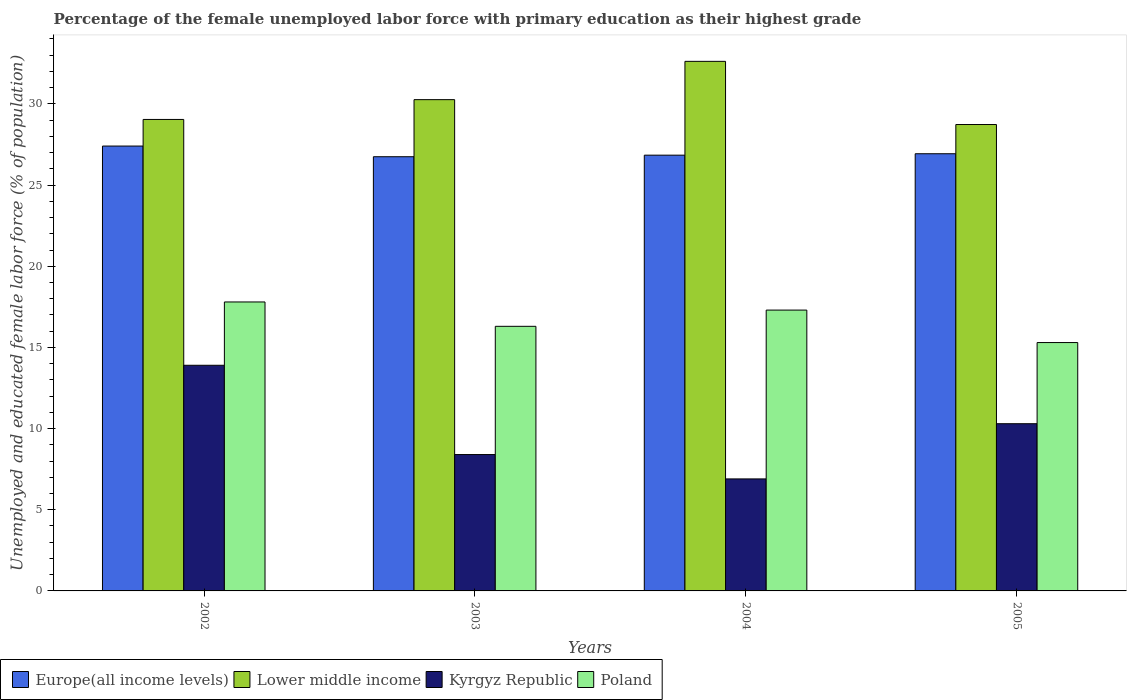How many groups of bars are there?
Make the answer very short. 4. In how many cases, is the number of bars for a given year not equal to the number of legend labels?
Give a very brief answer. 0. What is the percentage of the unemployed female labor force with primary education in Europe(all income levels) in 2002?
Offer a very short reply. 27.4. Across all years, what is the maximum percentage of the unemployed female labor force with primary education in Lower middle income?
Offer a very short reply. 32.62. Across all years, what is the minimum percentage of the unemployed female labor force with primary education in Poland?
Your answer should be very brief. 15.3. In which year was the percentage of the unemployed female labor force with primary education in Kyrgyz Republic maximum?
Provide a succinct answer. 2002. In which year was the percentage of the unemployed female labor force with primary education in Poland minimum?
Keep it short and to the point. 2005. What is the total percentage of the unemployed female labor force with primary education in Kyrgyz Republic in the graph?
Keep it short and to the point. 39.5. What is the difference between the percentage of the unemployed female labor force with primary education in Europe(all income levels) in 2004 and that in 2005?
Your answer should be very brief. -0.09. What is the difference between the percentage of the unemployed female labor force with primary education in Europe(all income levels) in 2003 and the percentage of the unemployed female labor force with primary education in Poland in 2002?
Your response must be concise. 8.95. What is the average percentage of the unemployed female labor force with primary education in Poland per year?
Make the answer very short. 16.67. In the year 2004, what is the difference between the percentage of the unemployed female labor force with primary education in Europe(all income levels) and percentage of the unemployed female labor force with primary education in Lower middle income?
Offer a very short reply. -5.78. In how many years, is the percentage of the unemployed female labor force with primary education in Lower middle income greater than 5 %?
Your response must be concise. 4. What is the ratio of the percentage of the unemployed female labor force with primary education in Europe(all income levels) in 2004 to that in 2005?
Your answer should be very brief. 1. Is the percentage of the unemployed female labor force with primary education in Lower middle income in 2002 less than that in 2004?
Your answer should be compact. Yes. Is the difference between the percentage of the unemployed female labor force with primary education in Europe(all income levels) in 2003 and 2004 greater than the difference between the percentage of the unemployed female labor force with primary education in Lower middle income in 2003 and 2004?
Your answer should be compact. Yes. What is the difference between the highest and the second highest percentage of the unemployed female labor force with primary education in Europe(all income levels)?
Your answer should be very brief. 0.47. What is the difference between the highest and the lowest percentage of the unemployed female labor force with primary education in Lower middle income?
Ensure brevity in your answer.  3.89. Is it the case that in every year, the sum of the percentage of the unemployed female labor force with primary education in Europe(all income levels) and percentage of the unemployed female labor force with primary education in Kyrgyz Republic is greater than the sum of percentage of the unemployed female labor force with primary education in Lower middle income and percentage of the unemployed female labor force with primary education in Poland?
Ensure brevity in your answer.  No. What does the 4th bar from the left in 2004 represents?
Keep it short and to the point. Poland. Is it the case that in every year, the sum of the percentage of the unemployed female labor force with primary education in Poland and percentage of the unemployed female labor force with primary education in Europe(all income levels) is greater than the percentage of the unemployed female labor force with primary education in Lower middle income?
Provide a short and direct response. Yes. Are all the bars in the graph horizontal?
Your answer should be very brief. No. How many years are there in the graph?
Offer a terse response. 4. What is the difference between two consecutive major ticks on the Y-axis?
Your response must be concise. 5. Are the values on the major ticks of Y-axis written in scientific E-notation?
Provide a succinct answer. No. Does the graph contain any zero values?
Make the answer very short. No. Where does the legend appear in the graph?
Provide a succinct answer. Bottom left. How many legend labels are there?
Give a very brief answer. 4. How are the legend labels stacked?
Offer a very short reply. Horizontal. What is the title of the graph?
Keep it short and to the point. Percentage of the female unemployed labor force with primary education as their highest grade. Does "High income: OECD" appear as one of the legend labels in the graph?
Ensure brevity in your answer.  No. What is the label or title of the Y-axis?
Ensure brevity in your answer.  Unemployed and educated female labor force (% of population). What is the Unemployed and educated female labor force (% of population) of Europe(all income levels) in 2002?
Make the answer very short. 27.4. What is the Unemployed and educated female labor force (% of population) of Lower middle income in 2002?
Offer a very short reply. 29.04. What is the Unemployed and educated female labor force (% of population) in Kyrgyz Republic in 2002?
Provide a succinct answer. 13.9. What is the Unemployed and educated female labor force (% of population) in Poland in 2002?
Offer a terse response. 17.8. What is the Unemployed and educated female labor force (% of population) of Europe(all income levels) in 2003?
Keep it short and to the point. 26.75. What is the Unemployed and educated female labor force (% of population) in Lower middle income in 2003?
Your answer should be very brief. 30.26. What is the Unemployed and educated female labor force (% of population) in Kyrgyz Republic in 2003?
Offer a terse response. 8.4. What is the Unemployed and educated female labor force (% of population) of Poland in 2003?
Give a very brief answer. 16.3. What is the Unemployed and educated female labor force (% of population) in Europe(all income levels) in 2004?
Your response must be concise. 26.84. What is the Unemployed and educated female labor force (% of population) in Lower middle income in 2004?
Provide a short and direct response. 32.62. What is the Unemployed and educated female labor force (% of population) of Kyrgyz Republic in 2004?
Offer a terse response. 6.9. What is the Unemployed and educated female labor force (% of population) in Poland in 2004?
Your response must be concise. 17.3. What is the Unemployed and educated female labor force (% of population) of Europe(all income levels) in 2005?
Offer a very short reply. 26.93. What is the Unemployed and educated female labor force (% of population) in Lower middle income in 2005?
Make the answer very short. 28.73. What is the Unemployed and educated female labor force (% of population) in Kyrgyz Republic in 2005?
Your answer should be compact. 10.3. What is the Unemployed and educated female labor force (% of population) in Poland in 2005?
Offer a terse response. 15.3. Across all years, what is the maximum Unemployed and educated female labor force (% of population) of Europe(all income levels)?
Your answer should be very brief. 27.4. Across all years, what is the maximum Unemployed and educated female labor force (% of population) of Lower middle income?
Make the answer very short. 32.62. Across all years, what is the maximum Unemployed and educated female labor force (% of population) in Kyrgyz Republic?
Your response must be concise. 13.9. Across all years, what is the maximum Unemployed and educated female labor force (% of population) of Poland?
Offer a terse response. 17.8. Across all years, what is the minimum Unemployed and educated female labor force (% of population) of Europe(all income levels)?
Offer a very short reply. 26.75. Across all years, what is the minimum Unemployed and educated female labor force (% of population) in Lower middle income?
Ensure brevity in your answer.  28.73. Across all years, what is the minimum Unemployed and educated female labor force (% of population) of Kyrgyz Republic?
Give a very brief answer. 6.9. Across all years, what is the minimum Unemployed and educated female labor force (% of population) in Poland?
Make the answer very short. 15.3. What is the total Unemployed and educated female labor force (% of population) in Europe(all income levels) in the graph?
Your response must be concise. 107.92. What is the total Unemployed and educated female labor force (% of population) in Lower middle income in the graph?
Provide a short and direct response. 120.66. What is the total Unemployed and educated female labor force (% of population) in Kyrgyz Republic in the graph?
Your response must be concise. 39.5. What is the total Unemployed and educated female labor force (% of population) of Poland in the graph?
Ensure brevity in your answer.  66.7. What is the difference between the Unemployed and educated female labor force (% of population) of Europe(all income levels) in 2002 and that in 2003?
Keep it short and to the point. 0.66. What is the difference between the Unemployed and educated female labor force (% of population) in Lower middle income in 2002 and that in 2003?
Offer a terse response. -1.22. What is the difference between the Unemployed and educated female labor force (% of population) in Europe(all income levels) in 2002 and that in 2004?
Ensure brevity in your answer.  0.56. What is the difference between the Unemployed and educated female labor force (% of population) of Lower middle income in 2002 and that in 2004?
Ensure brevity in your answer.  -3.58. What is the difference between the Unemployed and educated female labor force (% of population) of Kyrgyz Republic in 2002 and that in 2004?
Offer a very short reply. 7. What is the difference between the Unemployed and educated female labor force (% of population) in Europe(all income levels) in 2002 and that in 2005?
Offer a terse response. 0.47. What is the difference between the Unemployed and educated female labor force (% of population) in Lower middle income in 2002 and that in 2005?
Your answer should be compact. 0.31. What is the difference between the Unemployed and educated female labor force (% of population) of Kyrgyz Republic in 2002 and that in 2005?
Make the answer very short. 3.6. What is the difference between the Unemployed and educated female labor force (% of population) of Europe(all income levels) in 2003 and that in 2004?
Your answer should be compact. -0.1. What is the difference between the Unemployed and educated female labor force (% of population) of Lower middle income in 2003 and that in 2004?
Provide a succinct answer. -2.36. What is the difference between the Unemployed and educated female labor force (% of population) in Kyrgyz Republic in 2003 and that in 2004?
Your answer should be compact. 1.5. What is the difference between the Unemployed and educated female labor force (% of population) in Poland in 2003 and that in 2004?
Keep it short and to the point. -1. What is the difference between the Unemployed and educated female labor force (% of population) in Europe(all income levels) in 2003 and that in 2005?
Your response must be concise. -0.18. What is the difference between the Unemployed and educated female labor force (% of population) of Lower middle income in 2003 and that in 2005?
Your response must be concise. 1.53. What is the difference between the Unemployed and educated female labor force (% of population) in Kyrgyz Republic in 2003 and that in 2005?
Your response must be concise. -1.9. What is the difference between the Unemployed and educated female labor force (% of population) in Europe(all income levels) in 2004 and that in 2005?
Keep it short and to the point. -0.09. What is the difference between the Unemployed and educated female labor force (% of population) of Lower middle income in 2004 and that in 2005?
Give a very brief answer. 3.89. What is the difference between the Unemployed and educated female labor force (% of population) of Kyrgyz Republic in 2004 and that in 2005?
Your response must be concise. -3.4. What is the difference between the Unemployed and educated female labor force (% of population) in Poland in 2004 and that in 2005?
Give a very brief answer. 2. What is the difference between the Unemployed and educated female labor force (% of population) of Europe(all income levels) in 2002 and the Unemployed and educated female labor force (% of population) of Lower middle income in 2003?
Your response must be concise. -2.86. What is the difference between the Unemployed and educated female labor force (% of population) in Europe(all income levels) in 2002 and the Unemployed and educated female labor force (% of population) in Kyrgyz Republic in 2003?
Your response must be concise. 19. What is the difference between the Unemployed and educated female labor force (% of population) of Europe(all income levels) in 2002 and the Unemployed and educated female labor force (% of population) of Poland in 2003?
Provide a short and direct response. 11.1. What is the difference between the Unemployed and educated female labor force (% of population) in Lower middle income in 2002 and the Unemployed and educated female labor force (% of population) in Kyrgyz Republic in 2003?
Offer a terse response. 20.64. What is the difference between the Unemployed and educated female labor force (% of population) in Lower middle income in 2002 and the Unemployed and educated female labor force (% of population) in Poland in 2003?
Provide a succinct answer. 12.74. What is the difference between the Unemployed and educated female labor force (% of population) in Kyrgyz Republic in 2002 and the Unemployed and educated female labor force (% of population) in Poland in 2003?
Your answer should be compact. -2.4. What is the difference between the Unemployed and educated female labor force (% of population) of Europe(all income levels) in 2002 and the Unemployed and educated female labor force (% of population) of Lower middle income in 2004?
Your answer should be compact. -5.22. What is the difference between the Unemployed and educated female labor force (% of population) of Europe(all income levels) in 2002 and the Unemployed and educated female labor force (% of population) of Kyrgyz Republic in 2004?
Your answer should be very brief. 20.5. What is the difference between the Unemployed and educated female labor force (% of population) of Europe(all income levels) in 2002 and the Unemployed and educated female labor force (% of population) of Poland in 2004?
Offer a terse response. 10.1. What is the difference between the Unemployed and educated female labor force (% of population) of Lower middle income in 2002 and the Unemployed and educated female labor force (% of population) of Kyrgyz Republic in 2004?
Keep it short and to the point. 22.14. What is the difference between the Unemployed and educated female labor force (% of population) in Lower middle income in 2002 and the Unemployed and educated female labor force (% of population) in Poland in 2004?
Make the answer very short. 11.74. What is the difference between the Unemployed and educated female labor force (% of population) in Kyrgyz Republic in 2002 and the Unemployed and educated female labor force (% of population) in Poland in 2004?
Your answer should be very brief. -3.4. What is the difference between the Unemployed and educated female labor force (% of population) of Europe(all income levels) in 2002 and the Unemployed and educated female labor force (% of population) of Lower middle income in 2005?
Your answer should be compact. -1.33. What is the difference between the Unemployed and educated female labor force (% of population) in Europe(all income levels) in 2002 and the Unemployed and educated female labor force (% of population) in Kyrgyz Republic in 2005?
Offer a very short reply. 17.1. What is the difference between the Unemployed and educated female labor force (% of population) of Europe(all income levels) in 2002 and the Unemployed and educated female labor force (% of population) of Poland in 2005?
Your answer should be very brief. 12.1. What is the difference between the Unemployed and educated female labor force (% of population) of Lower middle income in 2002 and the Unemployed and educated female labor force (% of population) of Kyrgyz Republic in 2005?
Your answer should be compact. 18.74. What is the difference between the Unemployed and educated female labor force (% of population) in Lower middle income in 2002 and the Unemployed and educated female labor force (% of population) in Poland in 2005?
Provide a succinct answer. 13.74. What is the difference between the Unemployed and educated female labor force (% of population) of Kyrgyz Republic in 2002 and the Unemployed and educated female labor force (% of population) of Poland in 2005?
Offer a terse response. -1.4. What is the difference between the Unemployed and educated female labor force (% of population) in Europe(all income levels) in 2003 and the Unemployed and educated female labor force (% of population) in Lower middle income in 2004?
Your answer should be compact. -5.87. What is the difference between the Unemployed and educated female labor force (% of population) of Europe(all income levels) in 2003 and the Unemployed and educated female labor force (% of population) of Kyrgyz Republic in 2004?
Provide a short and direct response. 19.85. What is the difference between the Unemployed and educated female labor force (% of population) in Europe(all income levels) in 2003 and the Unemployed and educated female labor force (% of population) in Poland in 2004?
Offer a terse response. 9.45. What is the difference between the Unemployed and educated female labor force (% of population) in Lower middle income in 2003 and the Unemployed and educated female labor force (% of population) in Kyrgyz Republic in 2004?
Give a very brief answer. 23.36. What is the difference between the Unemployed and educated female labor force (% of population) of Lower middle income in 2003 and the Unemployed and educated female labor force (% of population) of Poland in 2004?
Your response must be concise. 12.96. What is the difference between the Unemployed and educated female labor force (% of population) of Europe(all income levels) in 2003 and the Unemployed and educated female labor force (% of population) of Lower middle income in 2005?
Provide a short and direct response. -1.98. What is the difference between the Unemployed and educated female labor force (% of population) in Europe(all income levels) in 2003 and the Unemployed and educated female labor force (% of population) in Kyrgyz Republic in 2005?
Provide a short and direct response. 16.45. What is the difference between the Unemployed and educated female labor force (% of population) of Europe(all income levels) in 2003 and the Unemployed and educated female labor force (% of population) of Poland in 2005?
Offer a very short reply. 11.45. What is the difference between the Unemployed and educated female labor force (% of population) in Lower middle income in 2003 and the Unemployed and educated female labor force (% of population) in Kyrgyz Republic in 2005?
Your answer should be very brief. 19.96. What is the difference between the Unemployed and educated female labor force (% of population) of Lower middle income in 2003 and the Unemployed and educated female labor force (% of population) of Poland in 2005?
Provide a succinct answer. 14.96. What is the difference between the Unemployed and educated female labor force (% of population) of Europe(all income levels) in 2004 and the Unemployed and educated female labor force (% of population) of Lower middle income in 2005?
Your answer should be very brief. -1.89. What is the difference between the Unemployed and educated female labor force (% of population) in Europe(all income levels) in 2004 and the Unemployed and educated female labor force (% of population) in Kyrgyz Republic in 2005?
Ensure brevity in your answer.  16.54. What is the difference between the Unemployed and educated female labor force (% of population) in Europe(all income levels) in 2004 and the Unemployed and educated female labor force (% of population) in Poland in 2005?
Make the answer very short. 11.54. What is the difference between the Unemployed and educated female labor force (% of population) of Lower middle income in 2004 and the Unemployed and educated female labor force (% of population) of Kyrgyz Republic in 2005?
Give a very brief answer. 22.32. What is the difference between the Unemployed and educated female labor force (% of population) of Lower middle income in 2004 and the Unemployed and educated female labor force (% of population) of Poland in 2005?
Offer a terse response. 17.32. What is the difference between the Unemployed and educated female labor force (% of population) in Kyrgyz Republic in 2004 and the Unemployed and educated female labor force (% of population) in Poland in 2005?
Offer a terse response. -8.4. What is the average Unemployed and educated female labor force (% of population) of Europe(all income levels) per year?
Your answer should be compact. 26.98. What is the average Unemployed and educated female labor force (% of population) in Lower middle income per year?
Your answer should be very brief. 30.16. What is the average Unemployed and educated female labor force (% of population) in Kyrgyz Republic per year?
Offer a terse response. 9.88. What is the average Unemployed and educated female labor force (% of population) in Poland per year?
Provide a short and direct response. 16.68. In the year 2002, what is the difference between the Unemployed and educated female labor force (% of population) in Europe(all income levels) and Unemployed and educated female labor force (% of population) in Lower middle income?
Your answer should be very brief. -1.64. In the year 2002, what is the difference between the Unemployed and educated female labor force (% of population) of Europe(all income levels) and Unemployed and educated female labor force (% of population) of Kyrgyz Republic?
Offer a terse response. 13.5. In the year 2002, what is the difference between the Unemployed and educated female labor force (% of population) in Europe(all income levels) and Unemployed and educated female labor force (% of population) in Poland?
Your answer should be very brief. 9.6. In the year 2002, what is the difference between the Unemployed and educated female labor force (% of population) of Lower middle income and Unemployed and educated female labor force (% of population) of Kyrgyz Republic?
Provide a succinct answer. 15.14. In the year 2002, what is the difference between the Unemployed and educated female labor force (% of population) of Lower middle income and Unemployed and educated female labor force (% of population) of Poland?
Keep it short and to the point. 11.24. In the year 2002, what is the difference between the Unemployed and educated female labor force (% of population) of Kyrgyz Republic and Unemployed and educated female labor force (% of population) of Poland?
Ensure brevity in your answer.  -3.9. In the year 2003, what is the difference between the Unemployed and educated female labor force (% of population) in Europe(all income levels) and Unemployed and educated female labor force (% of population) in Lower middle income?
Offer a very short reply. -3.52. In the year 2003, what is the difference between the Unemployed and educated female labor force (% of population) in Europe(all income levels) and Unemployed and educated female labor force (% of population) in Kyrgyz Republic?
Give a very brief answer. 18.35. In the year 2003, what is the difference between the Unemployed and educated female labor force (% of population) of Europe(all income levels) and Unemployed and educated female labor force (% of population) of Poland?
Your answer should be compact. 10.45. In the year 2003, what is the difference between the Unemployed and educated female labor force (% of population) of Lower middle income and Unemployed and educated female labor force (% of population) of Kyrgyz Republic?
Your answer should be very brief. 21.86. In the year 2003, what is the difference between the Unemployed and educated female labor force (% of population) of Lower middle income and Unemployed and educated female labor force (% of population) of Poland?
Your answer should be compact. 13.96. In the year 2004, what is the difference between the Unemployed and educated female labor force (% of population) in Europe(all income levels) and Unemployed and educated female labor force (% of population) in Lower middle income?
Your answer should be compact. -5.78. In the year 2004, what is the difference between the Unemployed and educated female labor force (% of population) of Europe(all income levels) and Unemployed and educated female labor force (% of population) of Kyrgyz Republic?
Make the answer very short. 19.94. In the year 2004, what is the difference between the Unemployed and educated female labor force (% of population) of Europe(all income levels) and Unemployed and educated female labor force (% of population) of Poland?
Ensure brevity in your answer.  9.54. In the year 2004, what is the difference between the Unemployed and educated female labor force (% of population) in Lower middle income and Unemployed and educated female labor force (% of population) in Kyrgyz Republic?
Provide a short and direct response. 25.72. In the year 2004, what is the difference between the Unemployed and educated female labor force (% of population) of Lower middle income and Unemployed and educated female labor force (% of population) of Poland?
Your answer should be very brief. 15.32. In the year 2005, what is the difference between the Unemployed and educated female labor force (% of population) in Europe(all income levels) and Unemployed and educated female labor force (% of population) in Lower middle income?
Your answer should be very brief. -1.8. In the year 2005, what is the difference between the Unemployed and educated female labor force (% of population) of Europe(all income levels) and Unemployed and educated female labor force (% of population) of Kyrgyz Republic?
Offer a very short reply. 16.63. In the year 2005, what is the difference between the Unemployed and educated female labor force (% of population) in Europe(all income levels) and Unemployed and educated female labor force (% of population) in Poland?
Your response must be concise. 11.63. In the year 2005, what is the difference between the Unemployed and educated female labor force (% of population) of Lower middle income and Unemployed and educated female labor force (% of population) of Kyrgyz Republic?
Provide a succinct answer. 18.43. In the year 2005, what is the difference between the Unemployed and educated female labor force (% of population) in Lower middle income and Unemployed and educated female labor force (% of population) in Poland?
Offer a terse response. 13.43. What is the ratio of the Unemployed and educated female labor force (% of population) of Europe(all income levels) in 2002 to that in 2003?
Ensure brevity in your answer.  1.02. What is the ratio of the Unemployed and educated female labor force (% of population) in Lower middle income in 2002 to that in 2003?
Provide a short and direct response. 0.96. What is the ratio of the Unemployed and educated female labor force (% of population) of Kyrgyz Republic in 2002 to that in 2003?
Offer a very short reply. 1.65. What is the ratio of the Unemployed and educated female labor force (% of population) of Poland in 2002 to that in 2003?
Provide a succinct answer. 1.09. What is the ratio of the Unemployed and educated female labor force (% of population) in Europe(all income levels) in 2002 to that in 2004?
Your answer should be very brief. 1.02. What is the ratio of the Unemployed and educated female labor force (% of population) in Lower middle income in 2002 to that in 2004?
Keep it short and to the point. 0.89. What is the ratio of the Unemployed and educated female labor force (% of population) of Kyrgyz Republic in 2002 to that in 2004?
Your answer should be compact. 2.01. What is the ratio of the Unemployed and educated female labor force (% of population) in Poland in 2002 to that in 2004?
Offer a very short reply. 1.03. What is the ratio of the Unemployed and educated female labor force (% of population) in Europe(all income levels) in 2002 to that in 2005?
Offer a terse response. 1.02. What is the ratio of the Unemployed and educated female labor force (% of population) of Lower middle income in 2002 to that in 2005?
Make the answer very short. 1.01. What is the ratio of the Unemployed and educated female labor force (% of population) of Kyrgyz Republic in 2002 to that in 2005?
Offer a very short reply. 1.35. What is the ratio of the Unemployed and educated female labor force (% of population) of Poland in 2002 to that in 2005?
Your answer should be very brief. 1.16. What is the ratio of the Unemployed and educated female labor force (% of population) in Lower middle income in 2003 to that in 2004?
Keep it short and to the point. 0.93. What is the ratio of the Unemployed and educated female labor force (% of population) of Kyrgyz Republic in 2003 to that in 2004?
Keep it short and to the point. 1.22. What is the ratio of the Unemployed and educated female labor force (% of population) in Poland in 2003 to that in 2004?
Provide a short and direct response. 0.94. What is the ratio of the Unemployed and educated female labor force (% of population) in Europe(all income levels) in 2003 to that in 2005?
Offer a terse response. 0.99. What is the ratio of the Unemployed and educated female labor force (% of population) in Lower middle income in 2003 to that in 2005?
Provide a short and direct response. 1.05. What is the ratio of the Unemployed and educated female labor force (% of population) of Kyrgyz Republic in 2003 to that in 2005?
Provide a short and direct response. 0.82. What is the ratio of the Unemployed and educated female labor force (% of population) in Poland in 2003 to that in 2005?
Your response must be concise. 1.07. What is the ratio of the Unemployed and educated female labor force (% of population) of Lower middle income in 2004 to that in 2005?
Your answer should be very brief. 1.14. What is the ratio of the Unemployed and educated female labor force (% of population) of Kyrgyz Republic in 2004 to that in 2005?
Offer a terse response. 0.67. What is the ratio of the Unemployed and educated female labor force (% of population) in Poland in 2004 to that in 2005?
Keep it short and to the point. 1.13. What is the difference between the highest and the second highest Unemployed and educated female labor force (% of population) in Europe(all income levels)?
Your response must be concise. 0.47. What is the difference between the highest and the second highest Unemployed and educated female labor force (% of population) of Lower middle income?
Give a very brief answer. 2.36. What is the difference between the highest and the second highest Unemployed and educated female labor force (% of population) of Kyrgyz Republic?
Make the answer very short. 3.6. What is the difference between the highest and the second highest Unemployed and educated female labor force (% of population) of Poland?
Offer a terse response. 0.5. What is the difference between the highest and the lowest Unemployed and educated female labor force (% of population) in Europe(all income levels)?
Your answer should be very brief. 0.66. What is the difference between the highest and the lowest Unemployed and educated female labor force (% of population) of Lower middle income?
Provide a short and direct response. 3.89. What is the difference between the highest and the lowest Unemployed and educated female labor force (% of population) in Poland?
Provide a succinct answer. 2.5. 